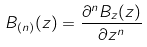Convert formula to latex. <formula><loc_0><loc_0><loc_500><loc_500>B _ { ( n ) } ( z ) = \frac { \partial ^ { n } B _ { z } ( z ) } { \partial z ^ { n } }</formula> 